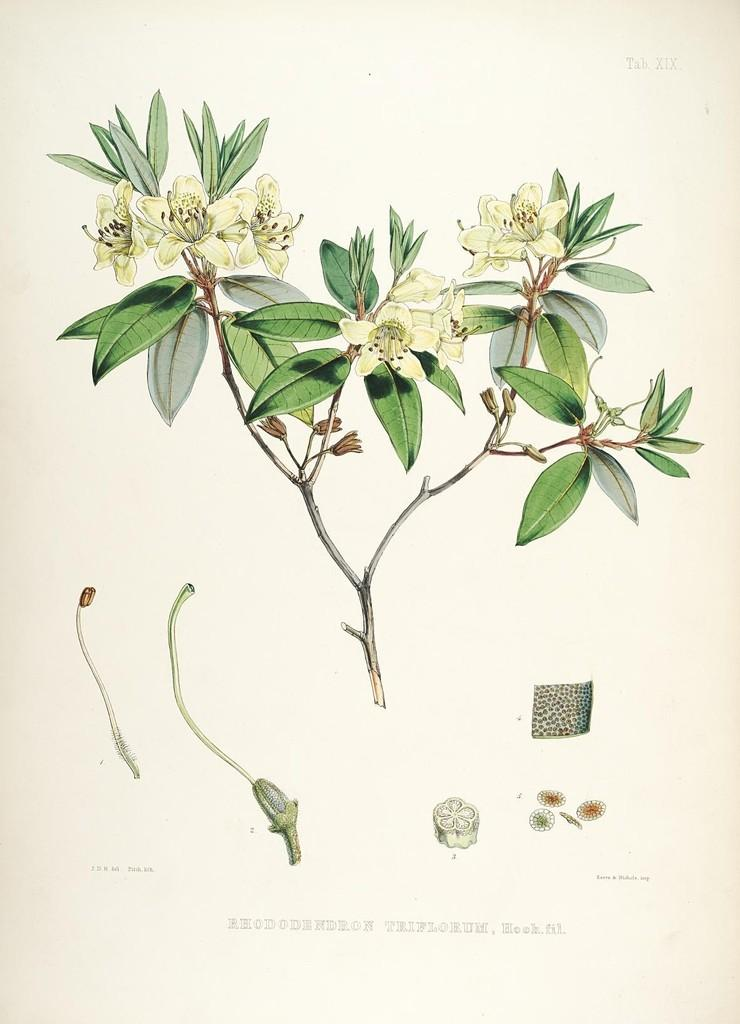What is depicted in the image? There is a drawing of a plant in the image. What specific parts of the plant are included in the drawing? The drawing includes parts of the plant. Can you see a dog in the background of the drawing? There is no dog present in the image; it is a drawing of a plant. Is there a hole in the drawing of the plant? The provided facts do not mention a hole in the drawing of the plant, so we cannot definitively answer that question. 